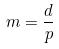Convert formula to latex. <formula><loc_0><loc_0><loc_500><loc_500>m = \frac { d } { p }</formula> 